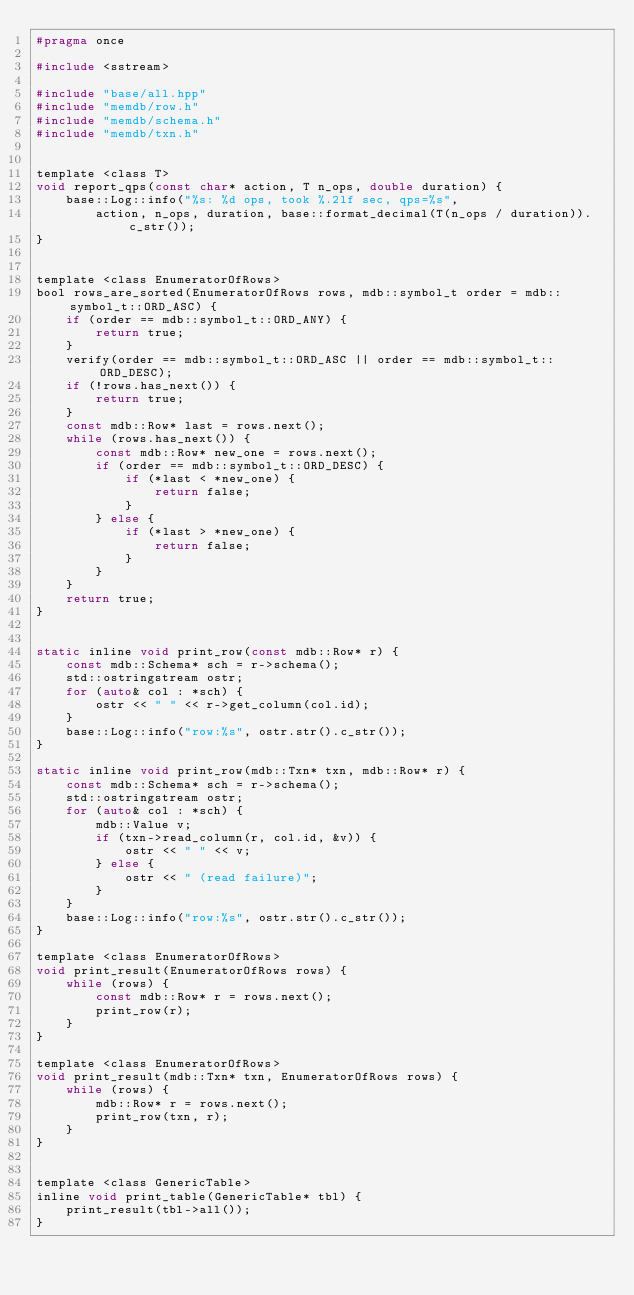<code> <loc_0><loc_0><loc_500><loc_500><_C_>#pragma once

#include <sstream>

#include "base/all.hpp"
#include "memdb/row.h"
#include "memdb/schema.h"
#include "memdb/txn.h"


template <class T>
void report_qps(const char* action, T n_ops, double duration) {
    base::Log::info("%s: %d ops, took %.2lf sec, qps=%s",
        action, n_ops, duration, base::format_decimal(T(n_ops / duration)).c_str());
}


template <class EnumeratorOfRows>
bool rows_are_sorted(EnumeratorOfRows rows, mdb::symbol_t order = mdb::symbol_t::ORD_ASC) {
    if (order == mdb::symbol_t::ORD_ANY) {
        return true;
    }
    verify(order == mdb::symbol_t::ORD_ASC || order == mdb::symbol_t::ORD_DESC);
    if (!rows.has_next()) {
        return true;
    }
    const mdb::Row* last = rows.next();
    while (rows.has_next()) {
        const mdb::Row* new_one = rows.next();
        if (order == mdb::symbol_t::ORD_DESC) {
            if (*last < *new_one) {
                return false;
            }
        } else {
            if (*last > *new_one) {
                return false;
            }
        }
    }
    return true;
}


static inline void print_row(const mdb::Row* r) {
    const mdb::Schema* sch = r->schema();
    std::ostringstream ostr;
    for (auto& col : *sch) {
        ostr << " " << r->get_column(col.id);
    }
    base::Log::info("row:%s", ostr.str().c_str());
}

static inline void print_row(mdb::Txn* txn, mdb::Row* r) {
    const mdb::Schema* sch = r->schema();
    std::ostringstream ostr;
    for (auto& col : *sch) {
        mdb::Value v;
        if (txn->read_column(r, col.id, &v)) {
            ostr << " " << v;
        } else {
            ostr << " (read failure)";
        }
    }
    base::Log::info("row:%s", ostr.str().c_str());
}

template <class EnumeratorOfRows>
void print_result(EnumeratorOfRows rows) {
    while (rows) {
        const mdb::Row* r = rows.next();
        print_row(r);
    }
}

template <class EnumeratorOfRows>
void print_result(mdb::Txn* txn, EnumeratorOfRows rows) {
    while (rows) {
        mdb::Row* r = rows.next();
        print_row(txn, r);
    }
}


template <class GenericTable>
inline void print_table(GenericTable* tbl) {
    print_result(tbl->all());
}
</code> 